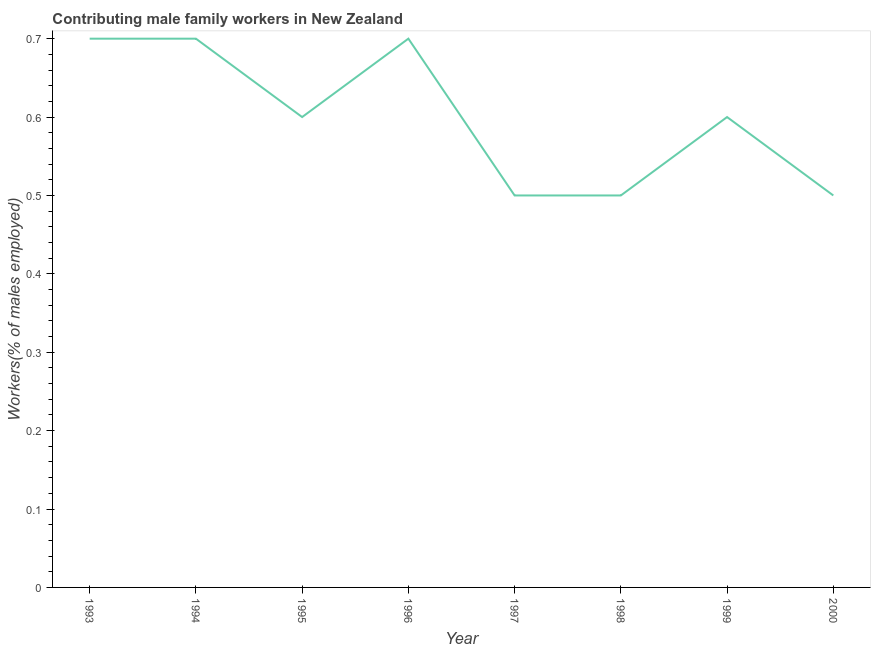What is the contributing male family workers in 1995?
Your answer should be very brief. 0.6. Across all years, what is the maximum contributing male family workers?
Provide a short and direct response. 0.7. Across all years, what is the minimum contributing male family workers?
Ensure brevity in your answer.  0.5. What is the sum of the contributing male family workers?
Offer a terse response. 4.8. What is the difference between the contributing male family workers in 1994 and 1998?
Offer a terse response. 0.2. What is the average contributing male family workers per year?
Your response must be concise. 0.6. What is the median contributing male family workers?
Your response must be concise. 0.6. What is the difference between the highest and the second highest contributing male family workers?
Your response must be concise. 0. Is the sum of the contributing male family workers in 1995 and 1997 greater than the maximum contributing male family workers across all years?
Keep it short and to the point. Yes. What is the difference between the highest and the lowest contributing male family workers?
Give a very brief answer. 0.2. In how many years, is the contributing male family workers greater than the average contributing male family workers taken over all years?
Your response must be concise. 5. How many lines are there?
Provide a succinct answer. 1. How many years are there in the graph?
Make the answer very short. 8. What is the difference between two consecutive major ticks on the Y-axis?
Give a very brief answer. 0.1. Are the values on the major ticks of Y-axis written in scientific E-notation?
Provide a short and direct response. No. Does the graph contain any zero values?
Your answer should be very brief. No. What is the title of the graph?
Offer a terse response. Contributing male family workers in New Zealand. What is the label or title of the Y-axis?
Your response must be concise. Workers(% of males employed). What is the Workers(% of males employed) in 1993?
Offer a terse response. 0.7. What is the Workers(% of males employed) of 1994?
Your answer should be very brief. 0.7. What is the Workers(% of males employed) of 1995?
Provide a succinct answer. 0.6. What is the Workers(% of males employed) in 1996?
Give a very brief answer. 0.7. What is the Workers(% of males employed) of 1997?
Make the answer very short. 0.5. What is the Workers(% of males employed) of 1999?
Your response must be concise. 0.6. What is the Workers(% of males employed) of 2000?
Provide a succinct answer. 0.5. What is the difference between the Workers(% of males employed) in 1993 and 1994?
Provide a succinct answer. 0. What is the difference between the Workers(% of males employed) in 1993 and 1995?
Ensure brevity in your answer.  0.1. What is the difference between the Workers(% of males employed) in 1994 and 1995?
Provide a short and direct response. 0.1. What is the difference between the Workers(% of males employed) in 1994 and 1996?
Your response must be concise. 0. What is the difference between the Workers(% of males employed) in 1994 and 1999?
Your answer should be very brief. 0.1. What is the difference between the Workers(% of males employed) in 1994 and 2000?
Offer a terse response. 0.2. What is the difference between the Workers(% of males employed) in 1995 and 1998?
Your answer should be compact. 0.1. What is the difference between the Workers(% of males employed) in 1996 and 1997?
Provide a short and direct response. 0.2. What is the difference between the Workers(% of males employed) in 1996 and 1998?
Provide a succinct answer. 0.2. What is the difference between the Workers(% of males employed) in 1998 and 2000?
Offer a terse response. 0. What is the ratio of the Workers(% of males employed) in 1993 to that in 1994?
Provide a succinct answer. 1. What is the ratio of the Workers(% of males employed) in 1993 to that in 1995?
Provide a succinct answer. 1.17. What is the ratio of the Workers(% of males employed) in 1993 to that in 1997?
Offer a terse response. 1.4. What is the ratio of the Workers(% of males employed) in 1993 to that in 1999?
Your answer should be very brief. 1.17. What is the ratio of the Workers(% of males employed) in 1993 to that in 2000?
Give a very brief answer. 1.4. What is the ratio of the Workers(% of males employed) in 1994 to that in 1995?
Give a very brief answer. 1.17. What is the ratio of the Workers(% of males employed) in 1994 to that in 1997?
Provide a succinct answer. 1.4. What is the ratio of the Workers(% of males employed) in 1994 to that in 1999?
Your response must be concise. 1.17. What is the ratio of the Workers(% of males employed) in 1994 to that in 2000?
Provide a succinct answer. 1.4. What is the ratio of the Workers(% of males employed) in 1995 to that in 1996?
Your answer should be very brief. 0.86. What is the ratio of the Workers(% of males employed) in 1995 to that in 1997?
Ensure brevity in your answer.  1.2. What is the ratio of the Workers(% of males employed) in 1995 to that in 1998?
Ensure brevity in your answer.  1.2. What is the ratio of the Workers(% of males employed) in 1995 to that in 2000?
Offer a terse response. 1.2. What is the ratio of the Workers(% of males employed) in 1996 to that in 1998?
Ensure brevity in your answer.  1.4. What is the ratio of the Workers(% of males employed) in 1996 to that in 1999?
Offer a very short reply. 1.17. What is the ratio of the Workers(% of males employed) in 1997 to that in 1999?
Make the answer very short. 0.83. What is the ratio of the Workers(% of males employed) in 1998 to that in 1999?
Make the answer very short. 0.83. What is the ratio of the Workers(% of males employed) in 1999 to that in 2000?
Make the answer very short. 1.2. 